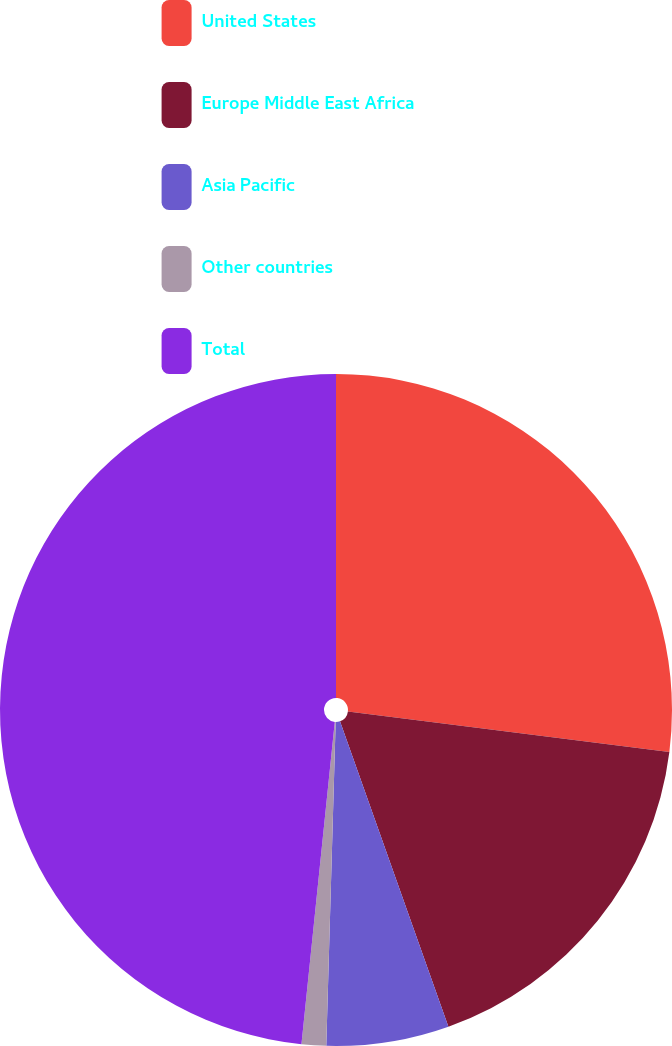Convert chart to OTSL. <chart><loc_0><loc_0><loc_500><loc_500><pie_chart><fcel>United States<fcel>Europe Middle East Africa<fcel>Asia Pacific<fcel>Other countries<fcel>Total<nl><fcel>26.99%<fcel>17.58%<fcel>5.89%<fcel>1.18%<fcel>48.36%<nl></chart> 